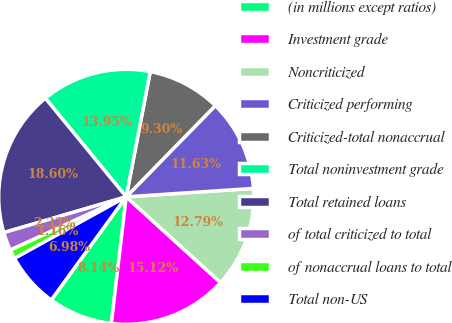Convert chart. <chart><loc_0><loc_0><loc_500><loc_500><pie_chart><fcel>(in millions except ratios)<fcel>Investment grade<fcel>Noncriticized<fcel>Criticized performing<fcel>Criticized-total nonaccrual<fcel>Total noninvestment grade<fcel>Total retained loans<fcel>of total criticized to total<fcel>of nonaccrual loans to total<fcel>Total non-US<nl><fcel>8.14%<fcel>15.12%<fcel>12.79%<fcel>11.63%<fcel>9.3%<fcel>13.95%<fcel>18.6%<fcel>2.33%<fcel>1.16%<fcel>6.98%<nl></chart> 